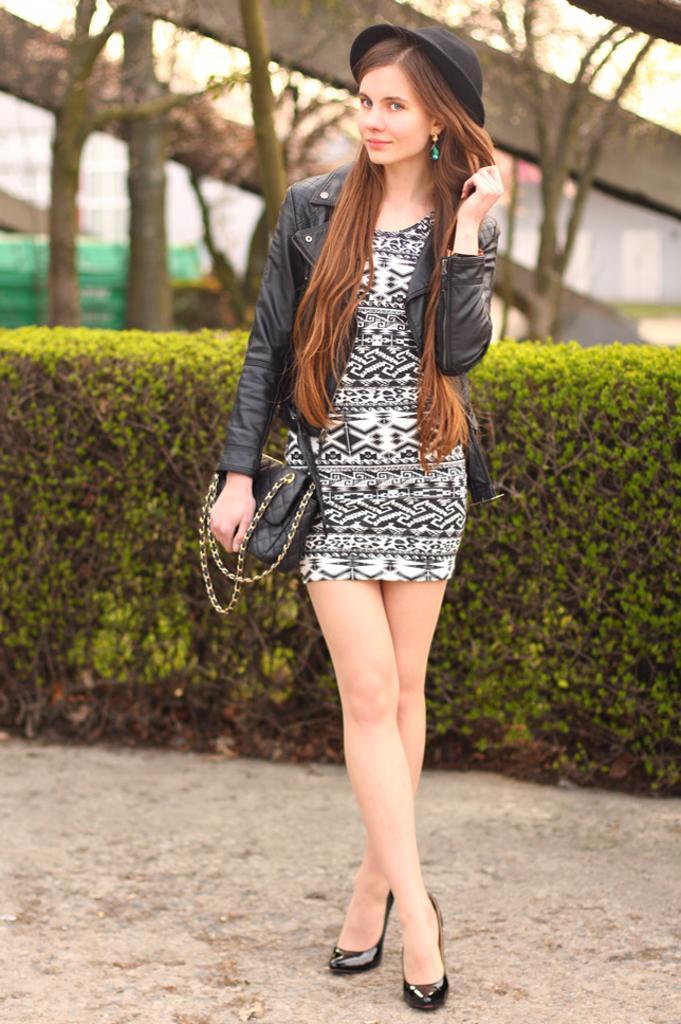Please provide a concise description of this image. In this image we can see a woman standing on the ground. In the background we can see bushes, trees and sky. 